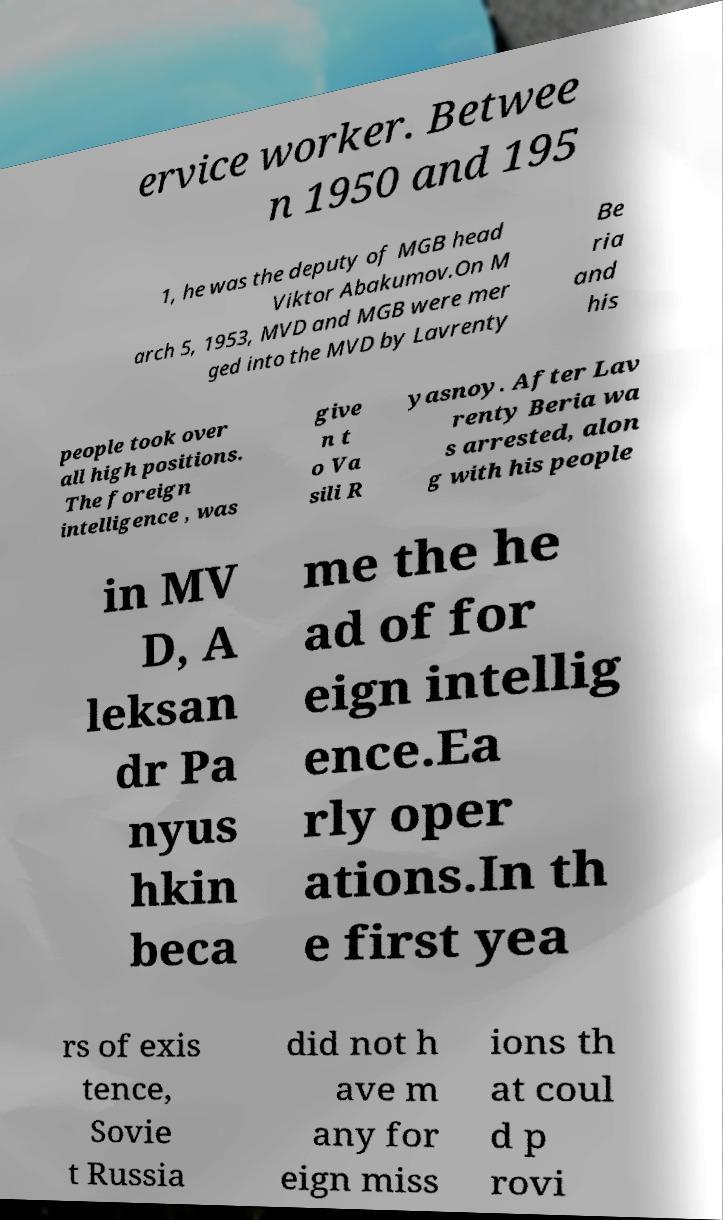Can you accurately transcribe the text from the provided image for me? ervice worker. Betwee n 1950 and 195 1, he was the deputy of MGB head Viktor Abakumov.On M arch 5, 1953, MVD and MGB were mer ged into the MVD by Lavrenty Be ria and his people took over all high positions. The foreign intelligence , was give n t o Va sili R yasnoy. After Lav renty Beria wa s arrested, alon g with his people in MV D, A leksan dr Pa nyus hkin beca me the he ad of for eign intellig ence.Ea rly oper ations.In th e first yea rs of exis tence, Sovie t Russia did not h ave m any for eign miss ions th at coul d p rovi 